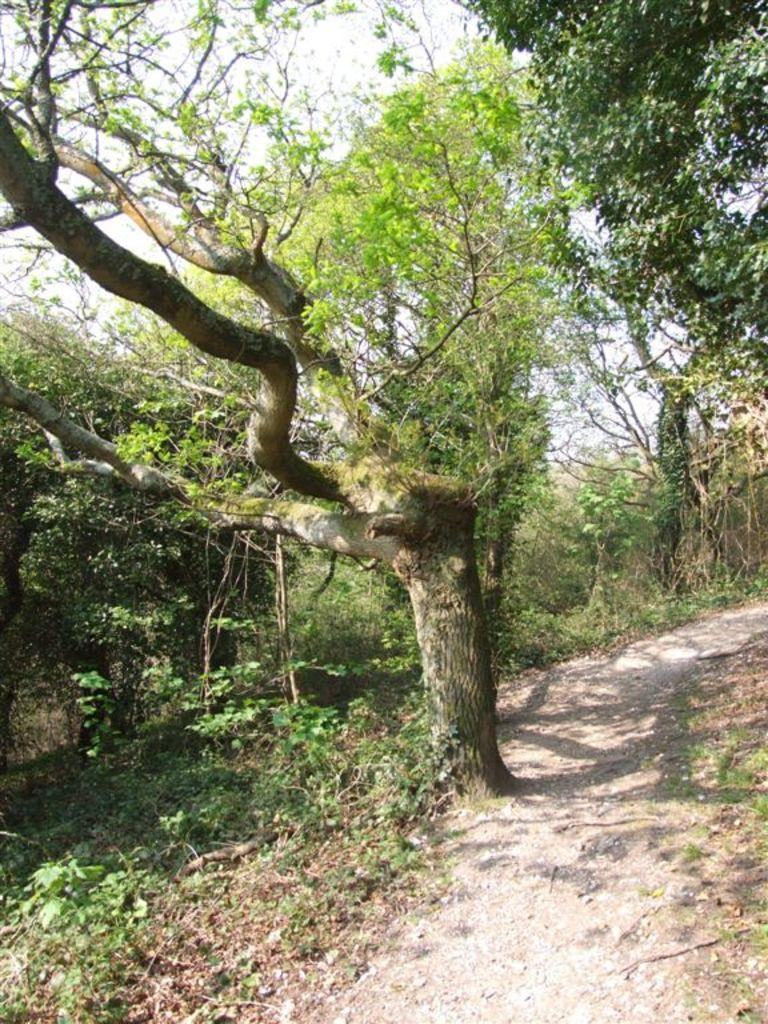What type of vegetation can be seen in the image? There are trees and plants in the image. Where are the plants located in the image? The plants are at the bottom of the image. What is visible at the top of the image? The sky is visible at the top of the image. Can you tell me which ear is visible in the image? There are no ears present in the image; it features trees, plants, and the sky. Who is the representative of the plants in the image? There is no representative present in the image; it simply shows trees and plants. 